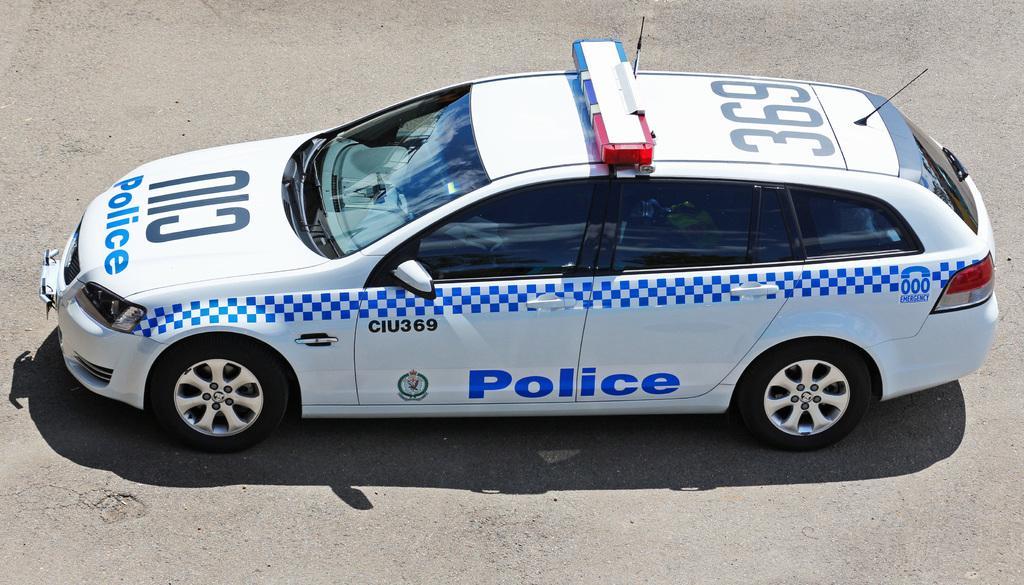Could you give a brief overview of what you see in this image? In this picture we can see a car which is in white color is on the road. 